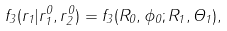<formula> <loc_0><loc_0><loc_500><loc_500>f _ { 3 } ( { r } _ { 1 } | { r } _ { 1 } ^ { 0 } , { r } _ { 2 } ^ { 0 } ) = f _ { 3 } ( R _ { 0 } , \phi _ { 0 } ; R _ { 1 } , \Theta _ { 1 } ) ,</formula> 